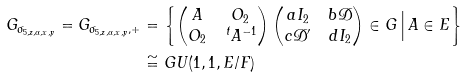<formula> <loc_0><loc_0><loc_500><loc_500>G _ { \sigma _ { 5 , z , \alpha , x , y } } = G _ { \sigma _ { 5 , z , \alpha , x , y } , + } & = \left \{ \begin{pmatrix} A & O _ { 2 } \\ O _ { 2 } & \, ^ { t } A ^ { - 1 } \end{pmatrix} \begin{pmatrix} a I _ { 2 } & b \mathcal { D } \\ c \mathcal { D } ^ { \prime } & d I _ { 2 } \end{pmatrix} \in G \, \Big | \, A \in E \right \} \\ & \cong G U ( 1 , 1 , E / F )</formula> 